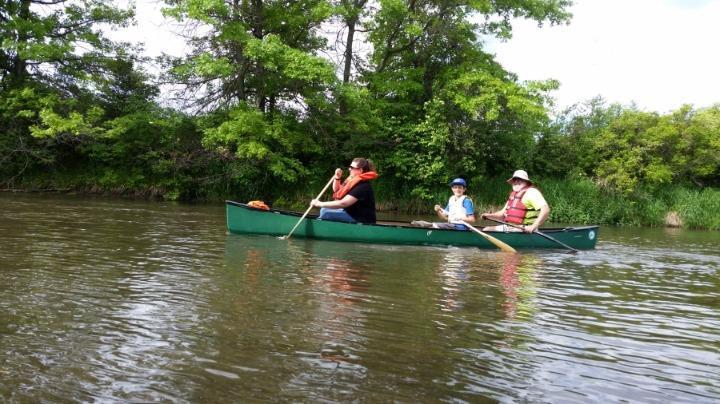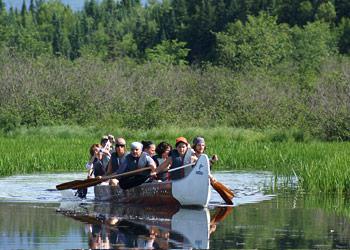The first image is the image on the left, the second image is the image on the right. Given the left and right images, does the statement "There are no more than than two people in the image on the right." hold true? Answer yes or no. No. The first image is the image on the left, the second image is the image on the right. Assess this claim about the two images: "Two canoes, each with one rider, are present in one image.". Correct or not? Answer yes or no. No. 